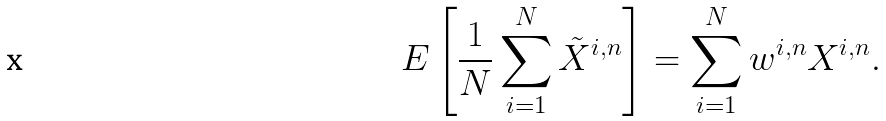Convert formula to latex. <formula><loc_0><loc_0><loc_500><loc_500>E \left [ \frac { 1 } { N } \sum ^ { N } _ { i = 1 } \tilde { X } ^ { i , n } \right ] = \sum _ { i = 1 } ^ { N } w ^ { i , n } X ^ { i , n } .</formula> 